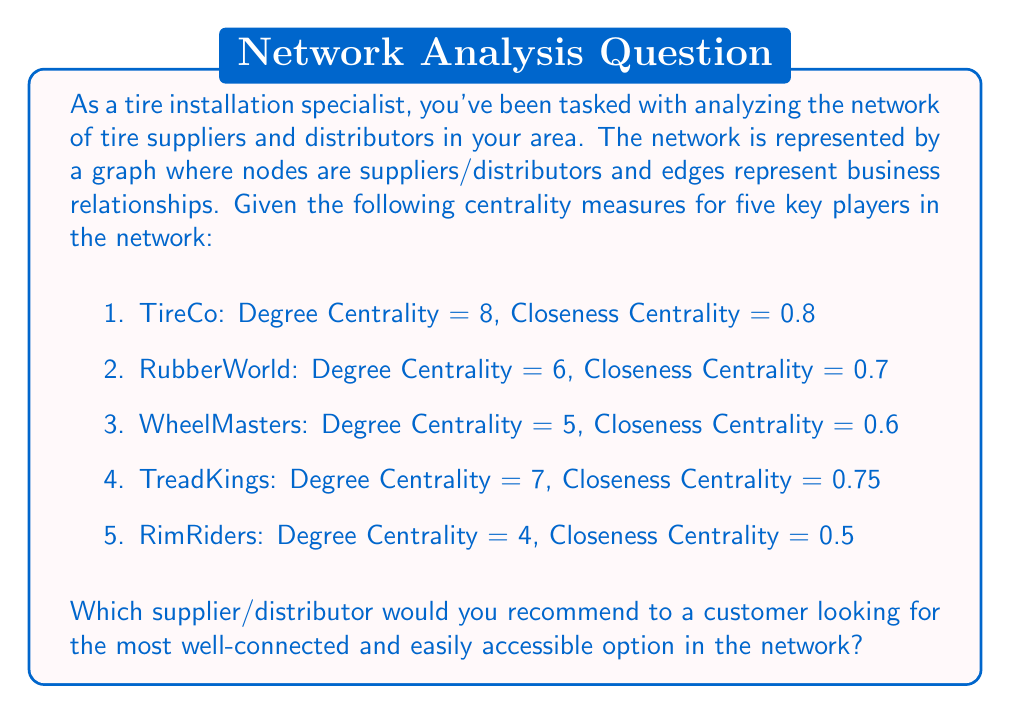Can you solve this math problem? To determine the most well-connected and easily accessible supplier/distributor, we need to consider both the degree centrality and closeness centrality measures:

1. Degree Centrality: This measure indicates the number of direct connections a node has in the network. A higher degree centrality suggests that the supplier/distributor has more business relationships.

2. Closeness Centrality: This measure represents how close a node is to all other nodes in the network. A higher closeness centrality indicates that the supplier/distributor can reach others in the network more quickly and efficiently.

Let's analyze each supplier/distributor:

1. TireCo: 
   Degree Centrality = 8 (highest)
   Closeness Centrality = 0.8 (highest)

2. RubberWorld:
   Degree Centrality = 6
   Closeness Centrality = 0.7

3. WheelMasters:
   Degree Centrality = 5
   Closeness Centrality = 0.6

4. TreadKings:
   Degree Centrality = 7 (second highest)
   Closeness Centrality = 0.75 (second highest)

5. RimRiders:
   Degree Centrality = 4 (lowest)
   Closeness Centrality = 0.5 (lowest)

TireCo has both the highest degree centrality and the highest closeness centrality. This means that TireCo has the most direct connections in the network and is also the most easily accessible to other nodes in the network.

TreadKings comes in second place for both measures, while RimRiders has the lowest scores in both categories.

Given this analysis, TireCo would be the best recommendation for a customer looking for the most well-connected and easily accessible option in the network.
Answer: TireCo 